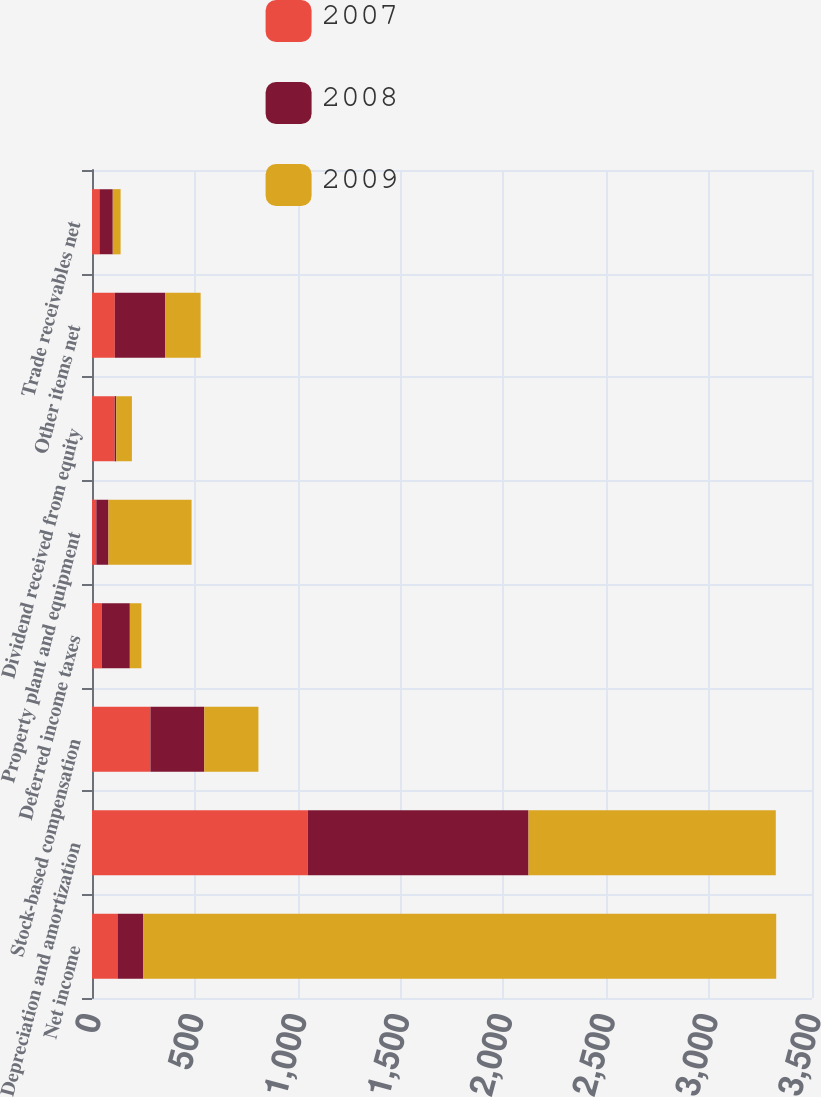<chart> <loc_0><loc_0><loc_500><loc_500><stacked_bar_chart><ecel><fcel>Net income<fcel>Depreciation and amortization<fcel>Stock-based compensation<fcel>Deferred income taxes<fcel>Property plant and equipment<fcel>Dividend received from equity<fcel>Other items net<fcel>Trade receivables net<nl><fcel>2007<fcel>124<fcel>1049<fcel>284<fcel>47<fcel>21<fcel>110<fcel>111<fcel>36<nl><fcel>2008<fcel>124<fcel>1073<fcel>262<fcel>137<fcel>59<fcel>8<fcel>244<fcel>65<nl><fcel>2009<fcel>3078<fcel>1202<fcel>263<fcel>56<fcel>404<fcel>76<fcel>173<fcel>38<nl></chart> 